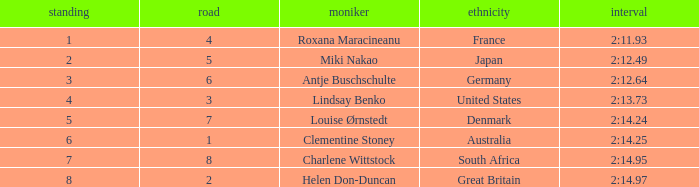What is the average Rank for a lane smaller than 3 with a nationality of Australia? 6.0. 